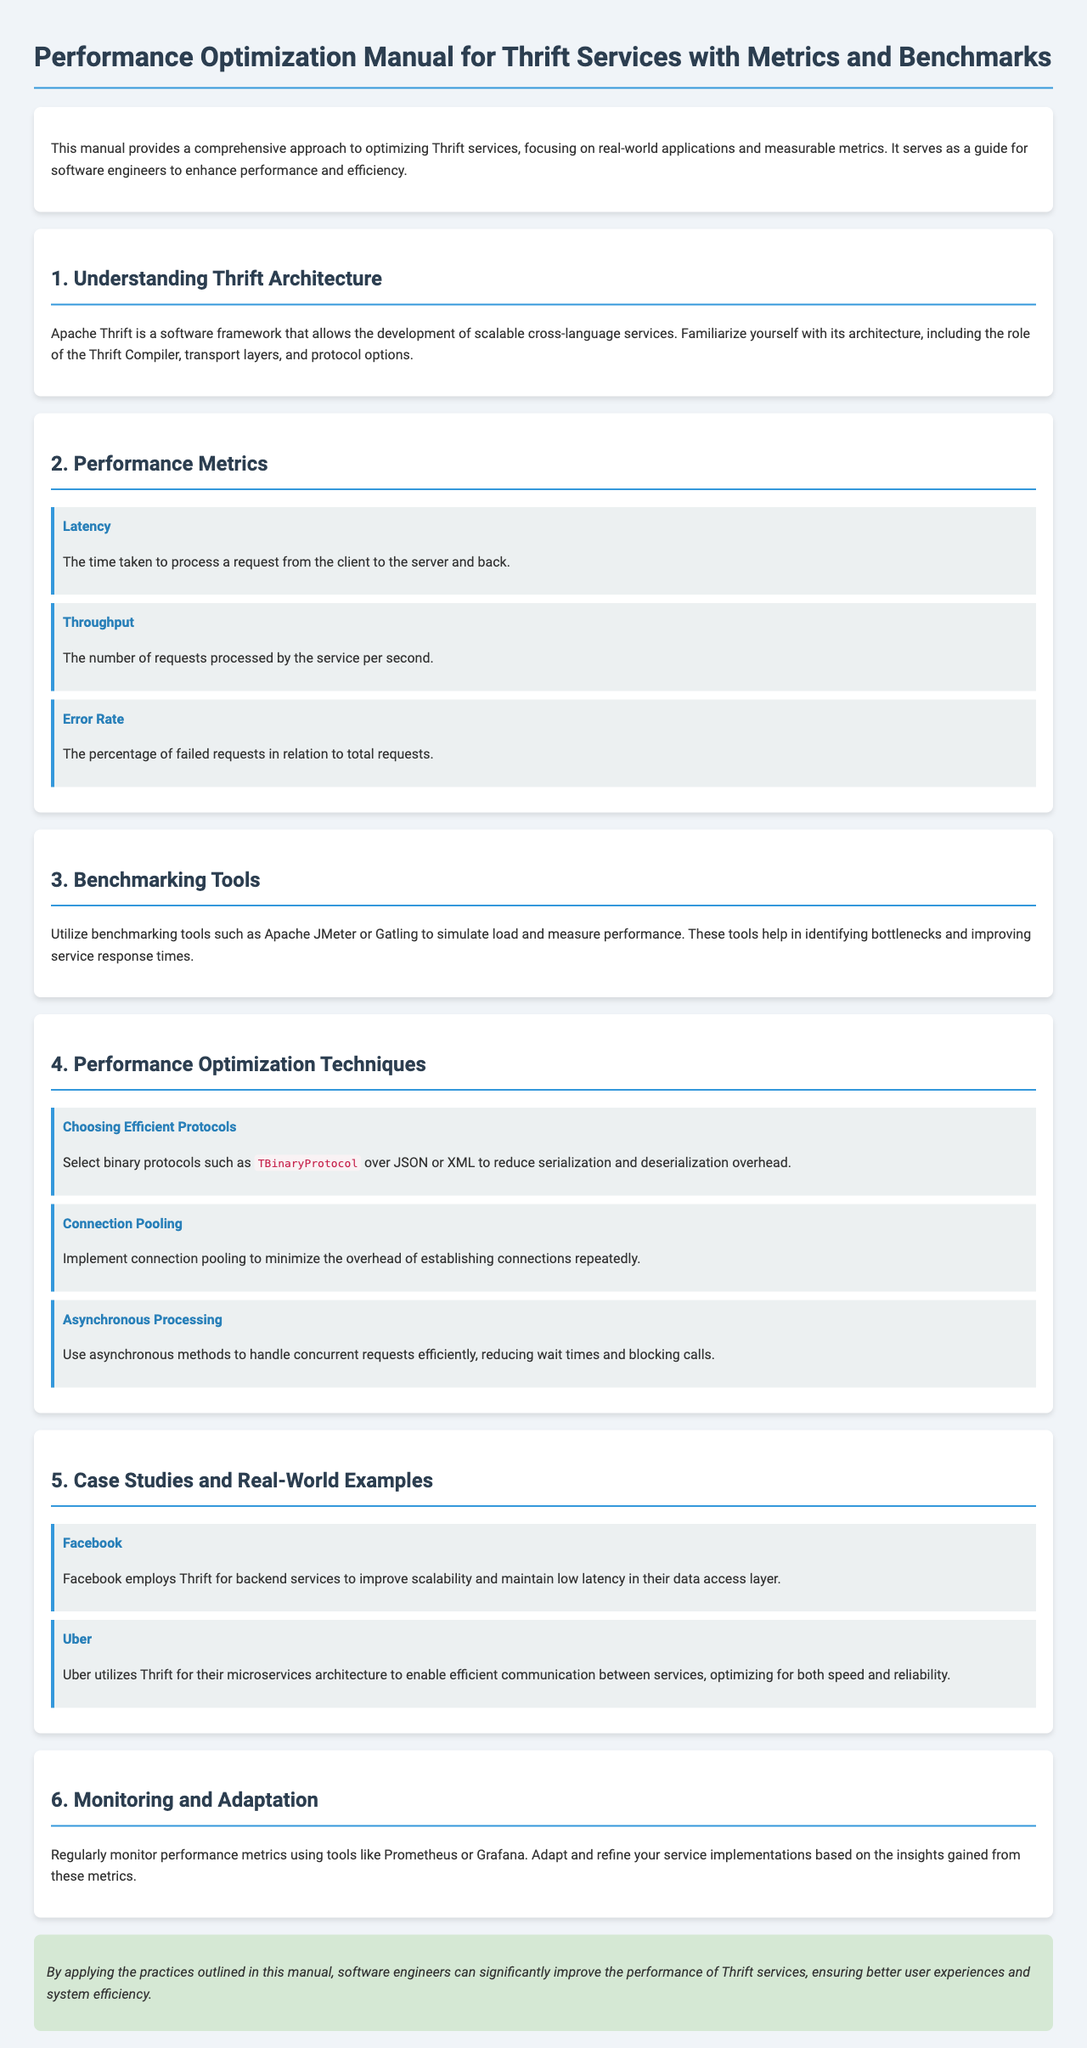What is the title of the manual? The title of the manual is explicitly stated at the top of the document.
Answer: Performance Optimization Manual for Thrift Services with Metrics and Benchmarks What is the first performance metric mentioned? The first metric is listed under the Performance Metrics section, which outlines various metrics.
Answer: Latency Which benchmarking tool is specifically mentioned? The document lists tools in the Benchmarking Tools section to help measure performance.
Answer: Apache JMeter What protocol does the manual recommend for reducing overhead? The recommended protocol is elaborated in the Performance Optimization Techniques section, specifically for efficiency.
Answer: TBinaryProtocol Which company is mentioned as a case study for Thrift usage? The case studies section provides examples of companies utilizing Thrift in their services.
Answer: Facebook What is one of the techniques suggested for processing requests? The Performance Optimization Techniques section emphasizes various methods to enhance performance and reduce bottlenecks.
Answer: Asynchronous Processing Which tool is suggested for monitoring performance metrics? The Monitoring and Adaptation section specifies tools that can be employed for performance monitoring.
Answer: Prometheus What is the main focus of the manual? The introduction gives a clear idea of the manual's overall goal and purpose.
Answer: Optimizing Thrift services 